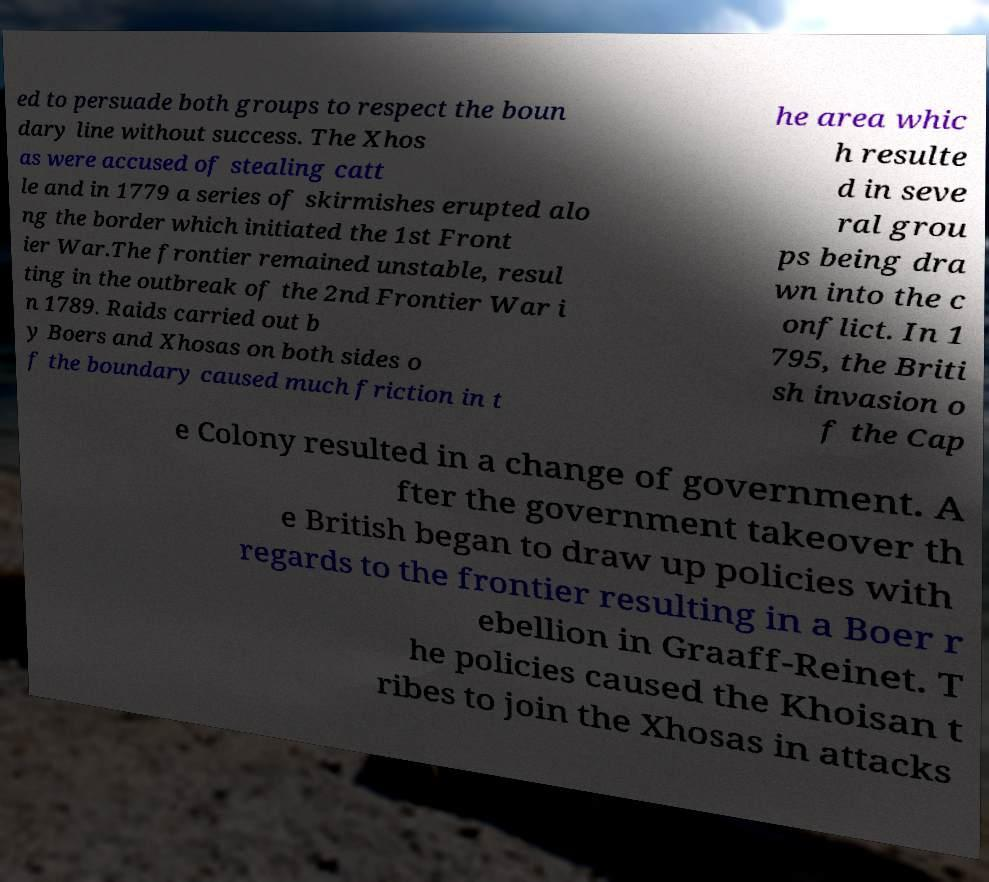Please read and relay the text visible in this image. What does it say? ed to persuade both groups to respect the boun dary line without success. The Xhos as were accused of stealing catt le and in 1779 a series of skirmishes erupted alo ng the border which initiated the 1st Front ier War.The frontier remained unstable, resul ting in the outbreak of the 2nd Frontier War i n 1789. Raids carried out b y Boers and Xhosas on both sides o f the boundary caused much friction in t he area whic h resulte d in seve ral grou ps being dra wn into the c onflict. In 1 795, the Briti sh invasion o f the Cap e Colony resulted in a change of government. A fter the government takeover th e British began to draw up policies with regards to the frontier resulting in a Boer r ebellion in Graaff-Reinet. T he policies caused the Khoisan t ribes to join the Xhosas in attacks 